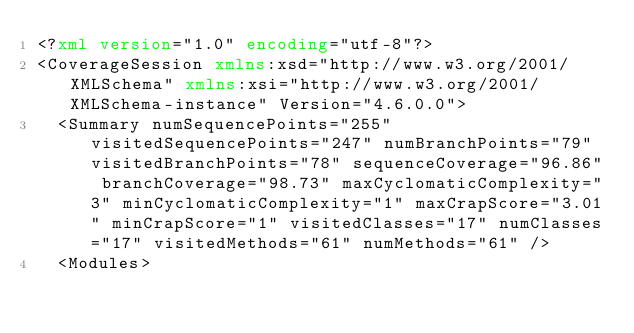Convert code to text. <code><loc_0><loc_0><loc_500><loc_500><_XML_><?xml version="1.0" encoding="utf-8"?>
<CoverageSession xmlns:xsd="http://www.w3.org/2001/XMLSchema" xmlns:xsi="http://www.w3.org/2001/XMLSchema-instance" Version="4.6.0.0">
  <Summary numSequencePoints="255" visitedSequencePoints="247" numBranchPoints="79" visitedBranchPoints="78" sequenceCoverage="96.86" branchCoverage="98.73" maxCyclomaticComplexity="3" minCyclomaticComplexity="1" maxCrapScore="3.01" minCrapScore="1" visitedClasses="17" numClasses="17" visitedMethods="61" numMethods="61" />
  <Modules></code> 